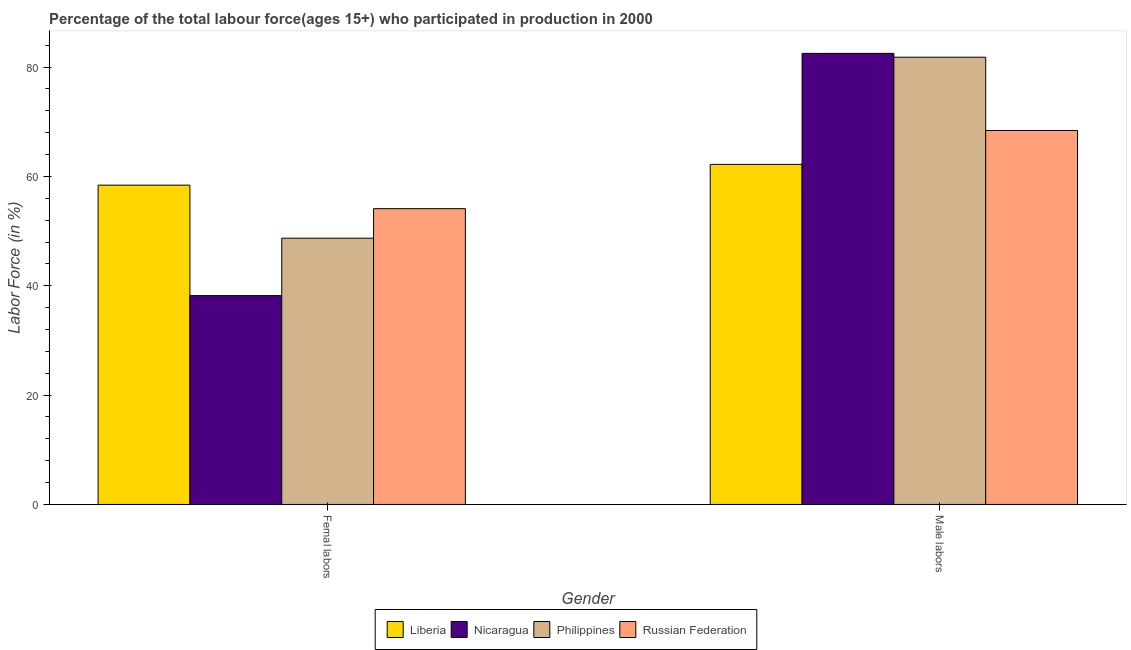How many groups of bars are there?
Provide a succinct answer. 2. How many bars are there on the 2nd tick from the left?
Keep it short and to the point. 4. What is the label of the 1st group of bars from the left?
Your answer should be compact. Femal labors. What is the percentage of female labor force in Russian Federation?
Ensure brevity in your answer.  54.1. Across all countries, what is the maximum percentage of female labor force?
Give a very brief answer. 58.4. Across all countries, what is the minimum percentage of male labour force?
Provide a short and direct response. 62.2. In which country was the percentage of male labour force maximum?
Offer a very short reply. Nicaragua. In which country was the percentage of female labor force minimum?
Your answer should be compact. Nicaragua. What is the total percentage of female labor force in the graph?
Your answer should be compact. 199.4. What is the difference between the percentage of male labour force in Nicaragua and that in Liberia?
Provide a succinct answer. 20.3. What is the difference between the percentage of male labour force in Nicaragua and the percentage of female labor force in Liberia?
Provide a succinct answer. 24.1. What is the average percentage of female labor force per country?
Offer a terse response. 49.85. What is the difference between the percentage of female labor force and percentage of male labour force in Nicaragua?
Provide a short and direct response. -44.3. What is the ratio of the percentage of male labour force in Russian Federation to that in Liberia?
Your answer should be very brief. 1.1. Is the percentage of female labor force in Philippines less than that in Liberia?
Your answer should be very brief. Yes. What does the 2nd bar from the left in Femal labors represents?
Offer a terse response. Nicaragua. What does the 3rd bar from the right in Femal labors represents?
Provide a succinct answer. Nicaragua. How many bars are there?
Ensure brevity in your answer.  8. Are the values on the major ticks of Y-axis written in scientific E-notation?
Ensure brevity in your answer.  No. Does the graph contain grids?
Offer a terse response. No. Where does the legend appear in the graph?
Your answer should be very brief. Bottom center. How many legend labels are there?
Your response must be concise. 4. What is the title of the graph?
Offer a terse response. Percentage of the total labour force(ages 15+) who participated in production in 2000. Does "Macao" appear as one of the legend labels in the graph?
Keep it short and to the point. No. What is the label or title of the Y-axis?
Provide a succinct answer. Labor Force (in %). What is the Labor Force (in %) in Liberia in Femal labors?
Provide a short and direct response. 58.4. What is the Labor Force (in %) in Nicaragua in Femal labors?
Keep it short and to the point. 38.2. What is the Labor Force (in %) in Philippines in Femal labors?
Give a very brief answer. 48.7. What is the Labor Force (in %) of Russian Federation in Femal labors?
Provide a short and direct response. 54.1. What is the Labor Force (in %) in Liberia in Male labors?
Offer a terse response. 62.2. What is the Labor Force (in %) in Nicaragua in Male labors?
Offer a terse response. 82.5. What is the Labor Force (in %) in Philippines in Male labors?
Offer a terse response. 81.8. What is the Labor Force (in %) of Russian Federation in Male labors?
Your answer should be very brief. 68.4. Across all Gender, what is the maximum Labor Force (in %) in Liberia?
Your response must be concise. 62.2. Across all Gender, what is the maximum Labor Force (in %) of Nicaragua?
Make the answer very short. 82.5. Across all Gender, what is the maximum Labor Force (in %) of Philippines?
Offer a terse response. 81.8. Across all Gender, what is the maximum Labor Force (in %) of Russian Federation?
Give a very brief answer. 68.4. Across all Gender, what is the minimum Labor Force (in %) in Liberia?
Offer a very short reply. 58.4. Across all Gender, what is the minimum Labor Force (in %) of Nicaragua?
Offer a terse response. 38.2. Across all Gender, what is the minimum Labor Force (in %) of Philippines?
Keep it short and to the point. 48.7. Across all Gender, what is the minimum Labor Force (in %) of Russian Federation?
Your answer should be compact. 54.1. What is the total Labor Force (in %) in Liberia in the graph?
Give a very brief answer. 120.6. What is the total Labor Force (in %) in Nicaragua in the graph?
Offer a very short reply. 120.7. What is the total Labor Force (in %) of Philippines in the graph?
Ensure brevity in your answer.  130.5. What is the total Labor Force (in %) in Russian Federation in the graph?
Your answer should be very brief. 122.5. What is the difference between the Labor Force (in %) in Liberia in Femal labors and that in Male labors?
Your response must be concise. -3.8. What is the difference between the Labor Force (in %) in Nicaragua in Femal labors and that in Male labors?
Keep it short and to the point. -44.3. What is the difference between the Labor Force (in %) of Philippines in Femal labors and that in Male labors?
Ensure brevity in your answer.  -33.1. What is the difference between the Labor Force (in %) of Russian Federation in Femal labors and that in Male labors?
Offer a very short reply. -14.3. What is the difference between the Labor Force (in %) in Liberia in Femal labors and the Labor Force (in %) in Nicaragua in Male labors?
Provide a succinct answer. -24.1. What is the difference between the Labor Force (in %) in Liberia in Femal labors and the Labor Force (in %) in Philippines in Male labors?
Make the answer very short. -23.4. What is the difference between the Labor Force (in %) in Nicaragua in Femal labors and the Labor Force (in %) in Philippines in Male labors?
Give a very brief answer. -43.6. What is the difference between the Labor Force (in %) of Nicaragua in Femal labors and the Labor Force (in %) of Russian Federation in Male labors?
Ensure brevity in your answer.  -30.2. What is the difference between the Labor Force (in %) of Philippines in Femal labors and the Labor Force (in %) of Russian Federation in Male labors?
Your answer should be compact. -19.7. What is the average Labor Force (in %) in Liberia per Gender?
Ensure brevity in your answer.  60.3. What is the average Labor Force (in %) of Nicaragua per Gender?
Your response must be concise. 60.35. What is the average Labor Force (in %) in Philippines per Gender?
Your answer should be compact. 65.25. What is the average Labor Force (in %) of Russian Federation per Gender?
Provide a short and direct response. 61.25. What is the difference between the Labor Force (in %) in Liberia and Labor Force (in %) in Nicaragua in Femal labors?
Your answer should be compact. 20.2. What is the difference between the Labor Force (in %) in Liberia and Labor Force (in %) in Russian Federation in Femal labors?
Your response must be concise. 4.3. What is the difference between the Labor Force (in %) of Nicaragua and Labor Force (in %) of Philippines in Femal labors?
Your response must be concise. -10.5. What is the difference between the Labor Force (in %) in Nicaragua and Labor Force (in %) in Russian Federation in Femal labors?
Provide a succinct answer. -15.9. What is the difference between the Labor Force (in %) in Philippines and Labor Force (in %) in Russian Federation in Femal labors?
Offer a terse response. -5.4. What is the difference between the Labor Force (in %) in Liberia and Labor Force (in %) in Nicaragua in Male labors?
Your answer should be very brief. -20.3. What is the difference between the Labor Force (in %) of Liberia and Labor Force (in %) of Philippines in Male labors?
Ensure brevity in your answer.  -19.6. What is the difference between the Labor Force (in %) in Liberia and Labor Force (in %) in Russian Federation in Male labors?
Provide a succinct answer. -6.2. What is the difference between the Labor Force (in %) of Nicaragua and Labor Force (in %) of Russian Federation in Male labors?
Your answer should be very brief. 14.1. What is the ratio of the Labor Force (in %) of Liberia in Femal labors to that in Male labors?
Your answer should be very brief. 0.94. What is the ratio of the Labor Force (in %) of Nicaragua in Femal labors to that in Male labors?
Offer a very short reply. 0.46. What is the ratio of the Labor Force (in %) of Philippines in Femal labors to that in Male labors?
Offer a very short reply. 0.6. What is the ratio of the Labor Force (in %) of Russian Federation in Femal labors to that in Male labors?
Your answer should be very brief. 0.79. What is the difference between the highest and the second highest Labor Force (in %) of Nicaragua?
Offer a terse response. 44.3. What is the difference between the highest and the second highest Labor Force (in %) in Philippines?
Provide a succinct answer. 33.1. What is the difference between the highest and the lowest Labor Force (in %) in Nicaragua?
Ensure brevity in your answer.  44.3. What is the difference between the highest and the lowest Labor Force (in %) in Philippines?
Provide a succinct answer. 33.1. 